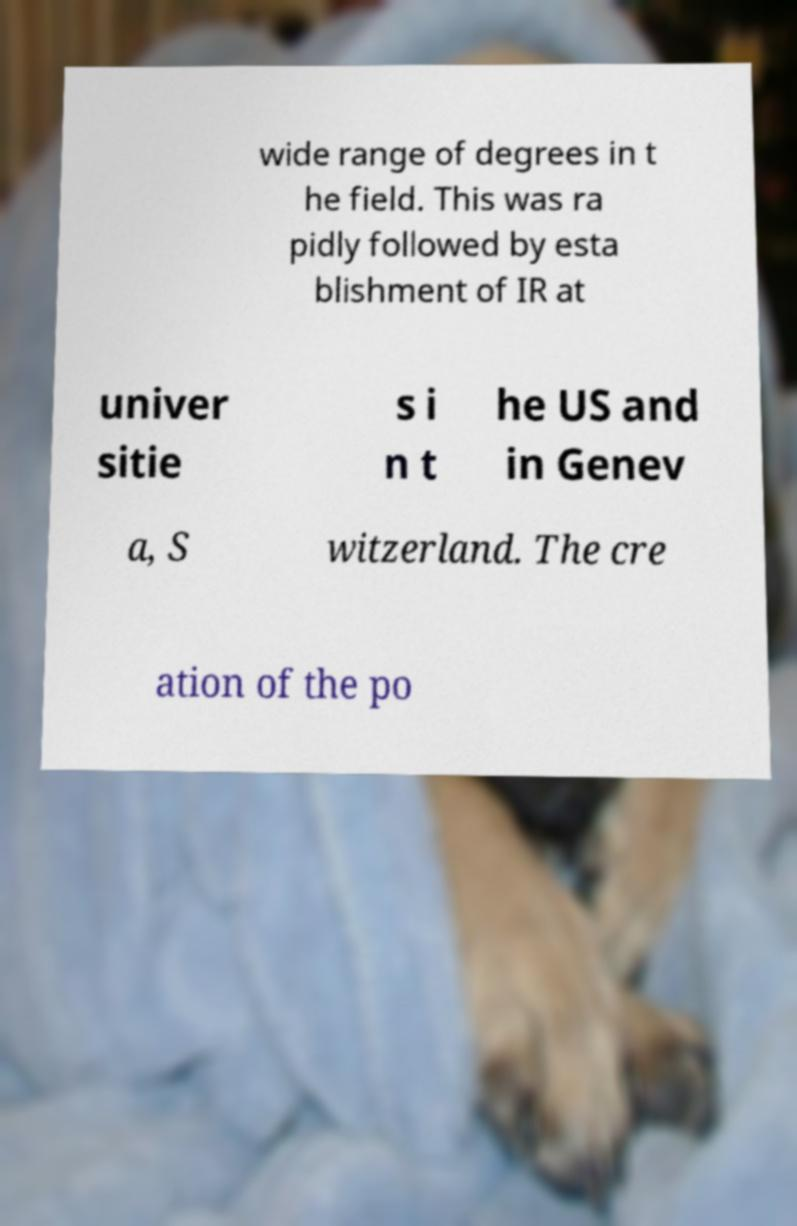I need the written content from this picture converted into text. Can you do that? wide range of degrees in t he field. This was ra pidly followed by esta blishment of IR at univer sitie s i n t he US and in Genev a, S witzerland. The cre ation of the po 